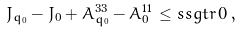<formula> <loc_0><loc_0><loc_500><loc_500>J _ { { q } _ { 0 } } - J _ { 0 } + A _ { { q } _ { 0 } } ^ { 3 3 } - A _ { 0 } ^ { 1 1 } \, \leq s s g t r \, 0 \, ,</formula> 